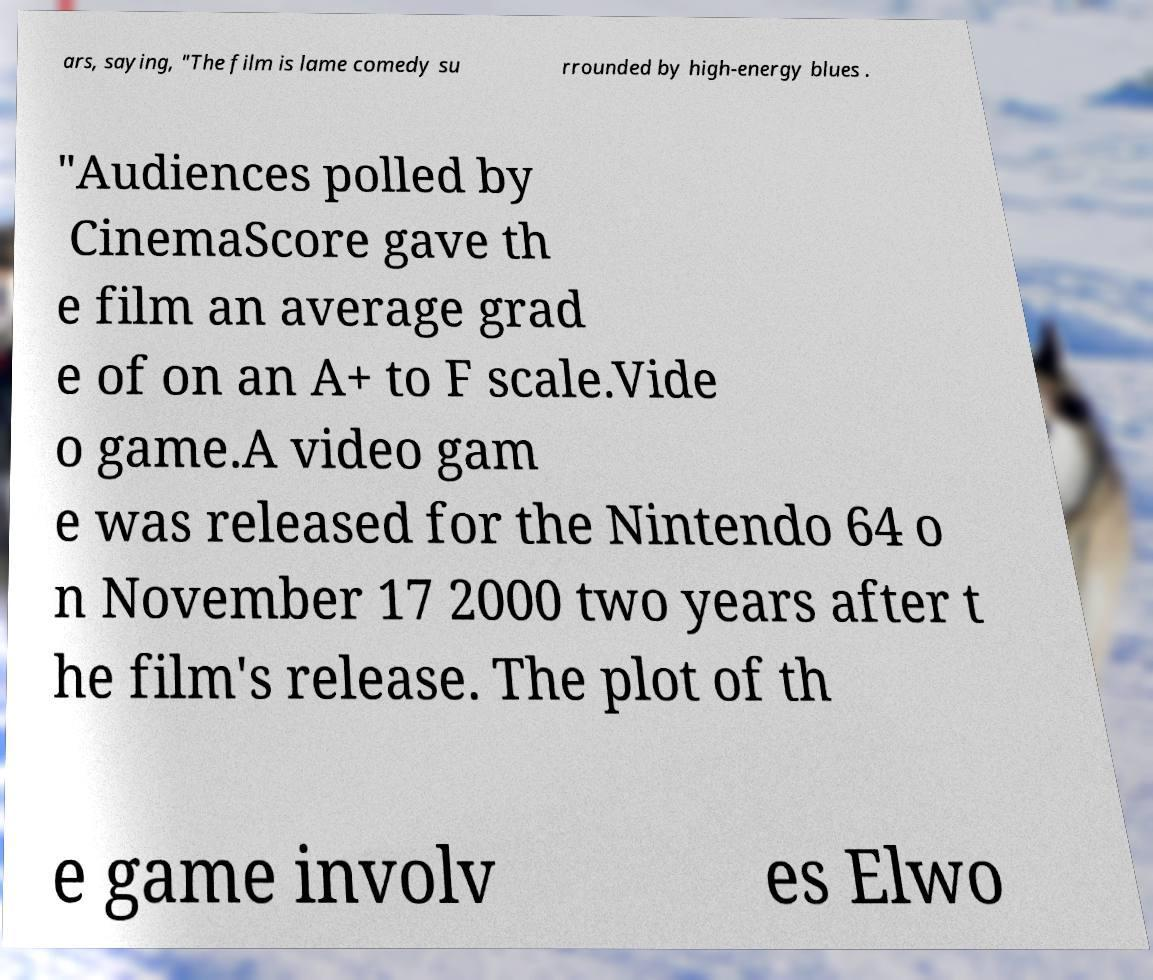There's text embedded in this image that I need extracted. Can you transcribe it verbatim? ars, saying, "The film is lame comedy su rrounded by high-energy blues . "Audiences polled by CinemaScore gave th e film an average grad e of on an A+ to F scale.Vide o game.A video gam e was released for the Nintendo 64 o n November 17 2000 two years after t he film's release. The plot of th e game involv es Elwo 